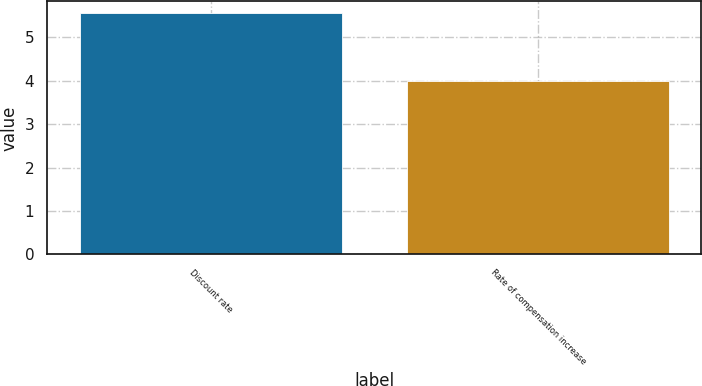Convert chart to OTSL. <chart><loc_0><loc_0><loc_500><loc_500><bar_chart><fcel>Discount rate<fcel>Rate of compensation increase<nl><fcel>5.55<fcel>4<nl></chart> 